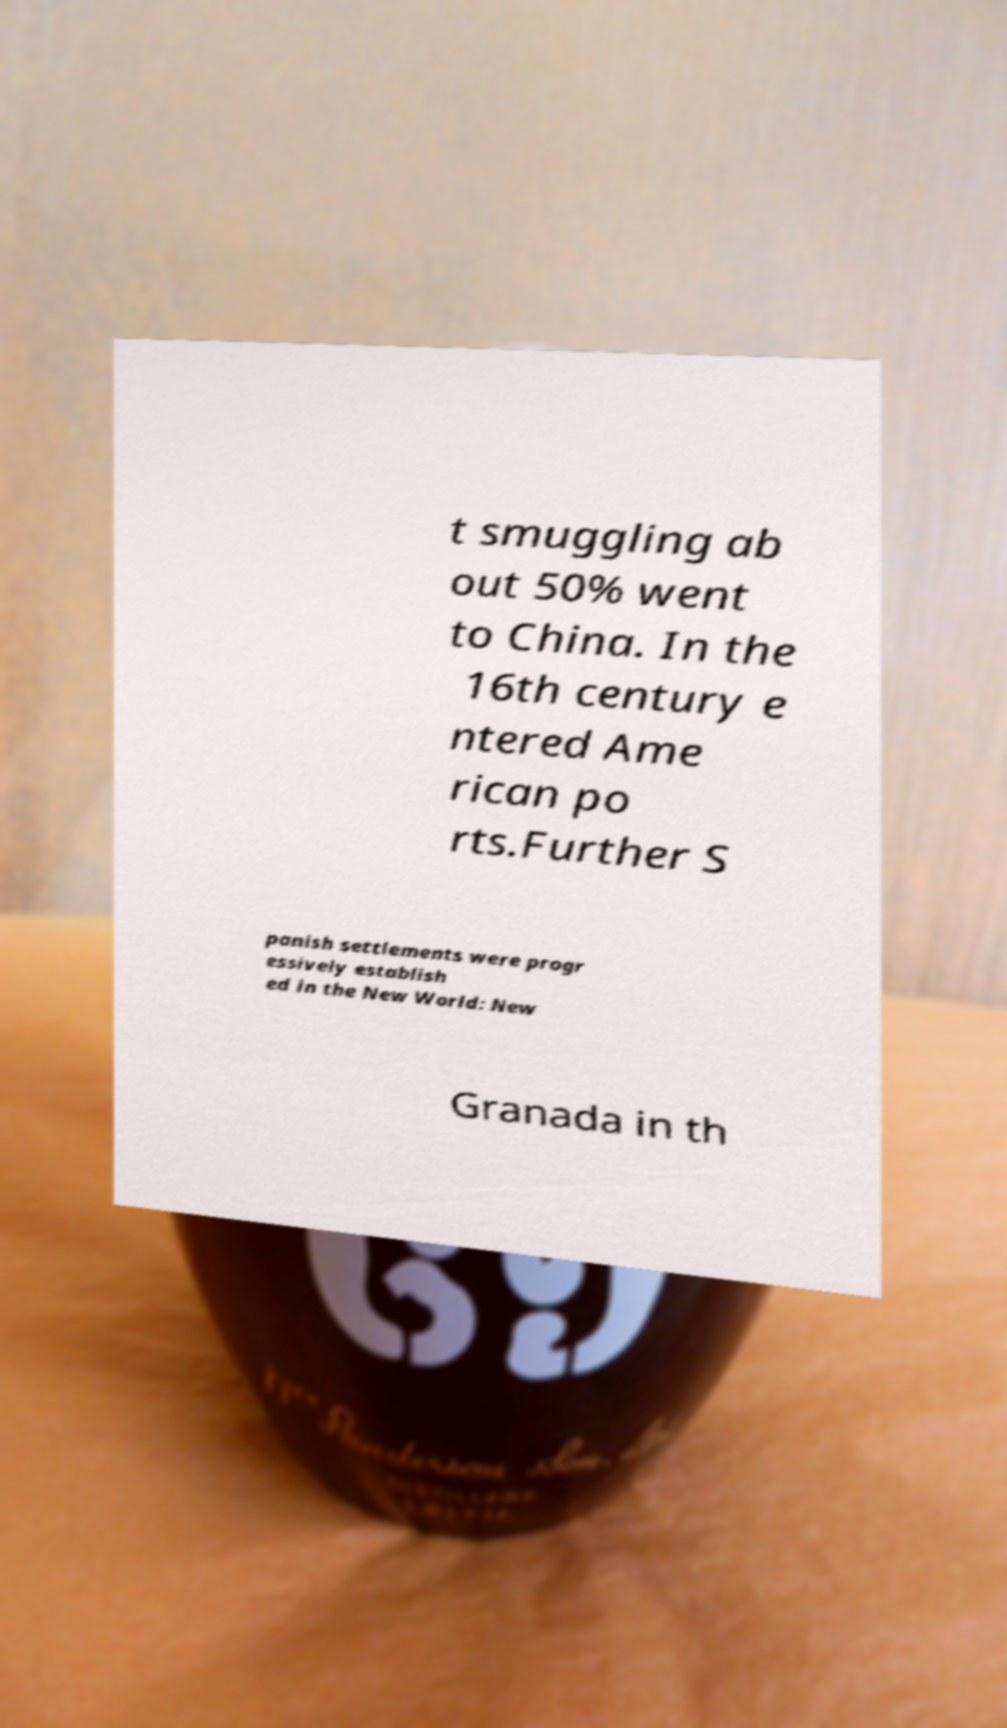What messages or text are displayed in this image? I need them in a readable, typed format. t smuggling ab out 50% went to China. In the 16th century e ntered Ame rican po rts.Further S panish settlements were progr essively establish ed in the New World: New Granada in th 